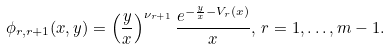<formula> <loc_0><loc_0><loc_500><loc_500>\phi _ { r , r + 1 } ( x , y ) = \left ( \frac { y } { x } \right ) ^ { \nu _ { r + 1 } } \frac { e ^ { - \frac { y } { x } - V _ { r } ( x ) } } { x } , \, r = 1 , \dots , m - 1 .</formula> 